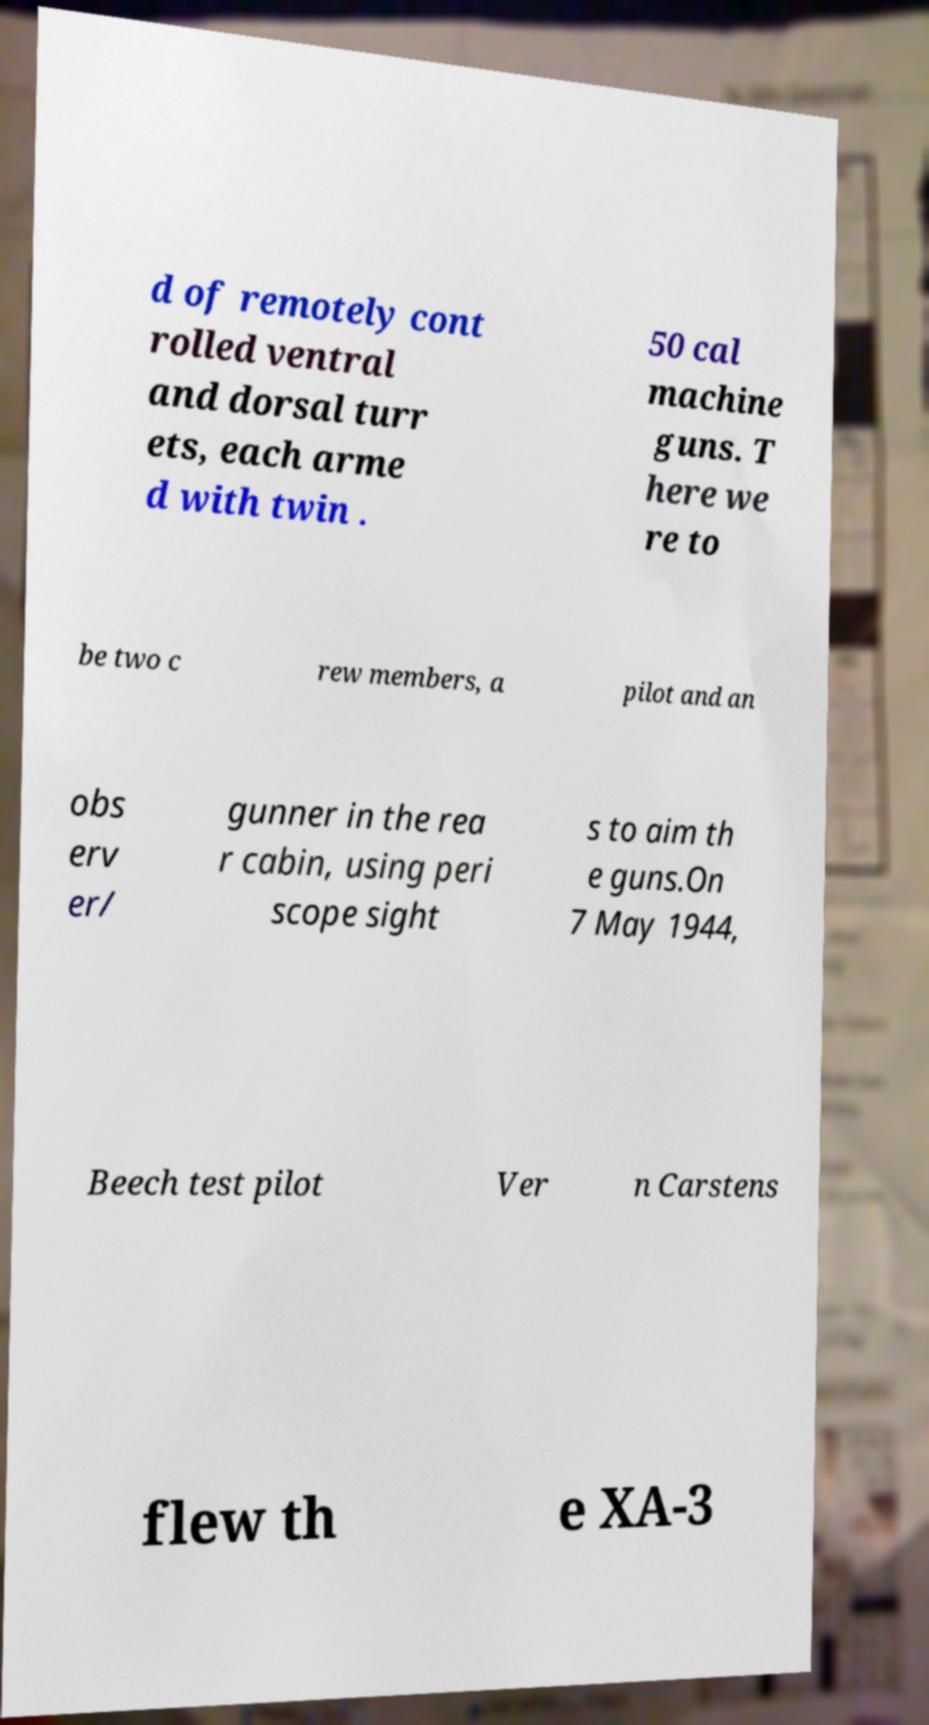For documentation purposes, I need the text within this image transcribed. Could you provide that? d of remotely cont rolled ventral and dorsal turr ets, each arme d with twin . 50 cal machine guns. T here we re to be two c rew members, a pilot and an obs erv er/ gunner in the rea r cabin, using peri scope sight s to aim th e guns.On 7 May 1944, Beech test pilot Ver n Carstens flew th e XA-3 